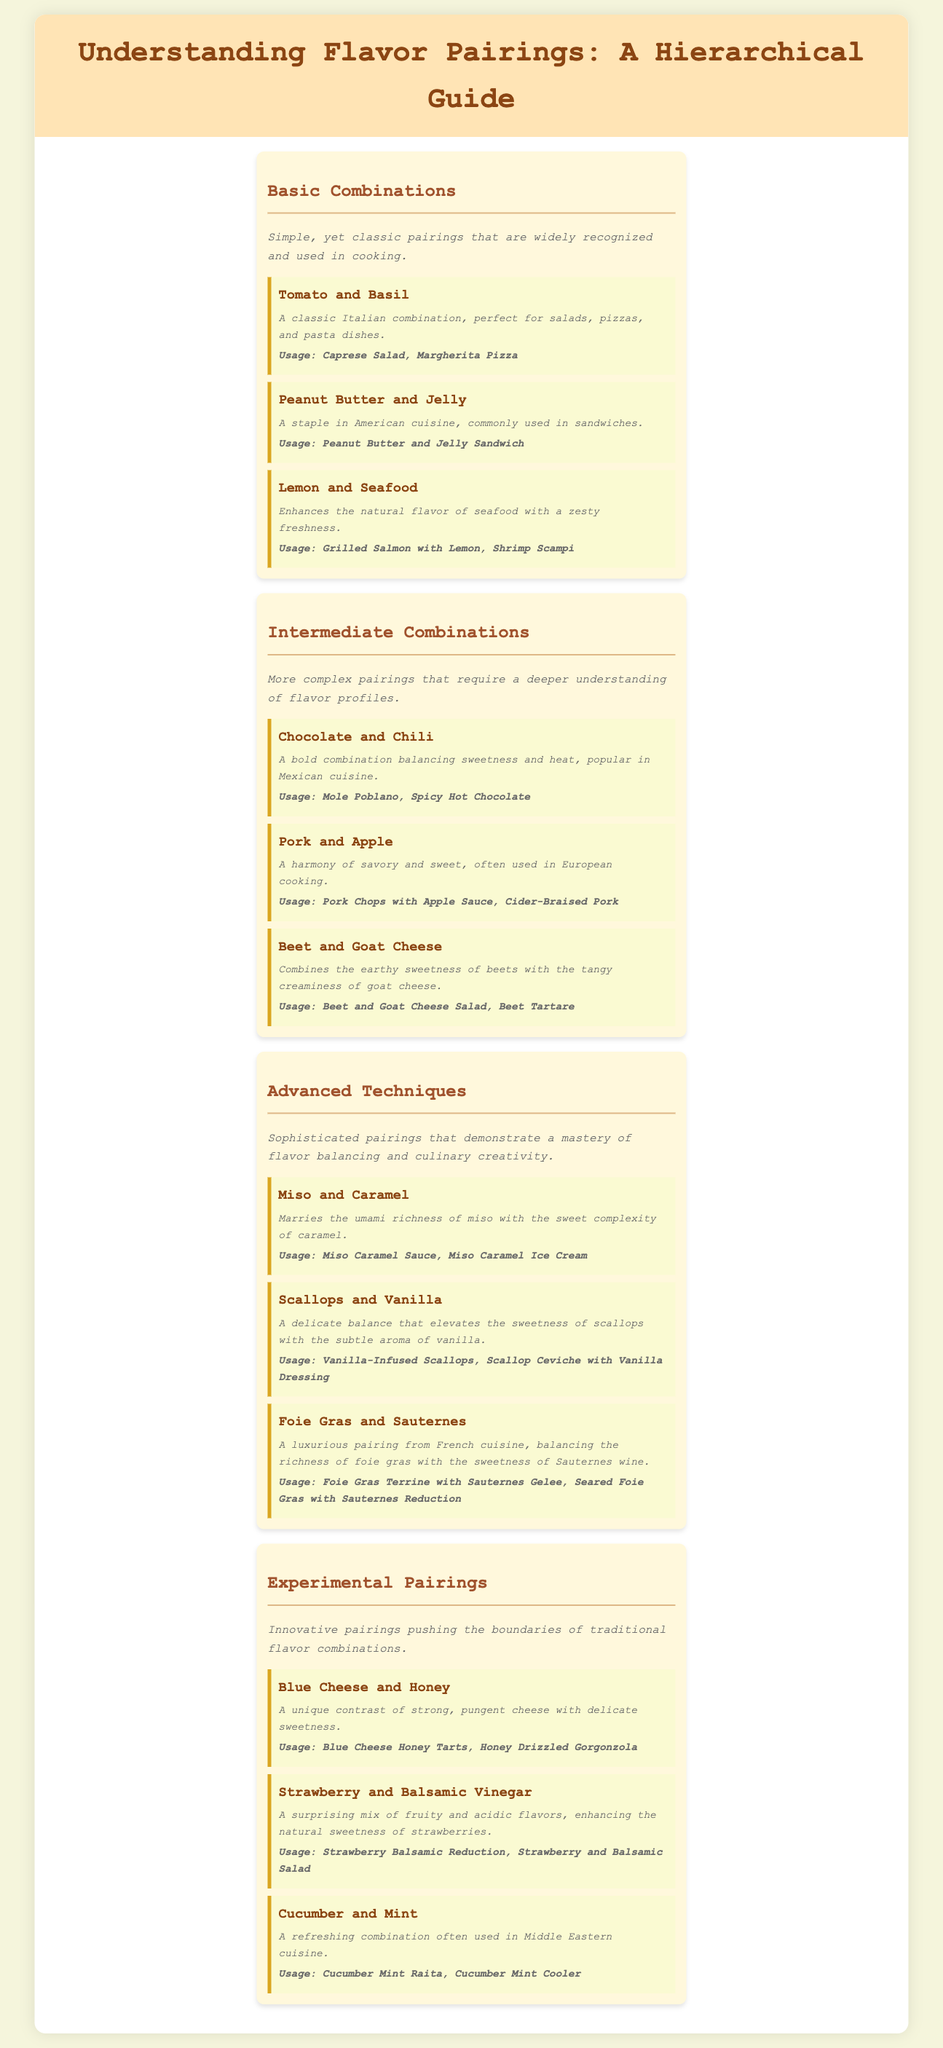What are the sections of the guide? The document contains sections that include Basic Combinations, Intermediate Combinations, Advanced Techniques, and Experimental Pairings.
Answer: Basic Combinations, Intermediate Combinations, Advanced Techniques, Experimental Pairings What is a classic pairing in Basic Combinations? The document lists Tomato and Basil as a classic pairing in Basic Combinations, which is widely recognized.
Answer: Tomato and Basil Which advanced technique combines miso with caramel? The document specifically mentions Miso and Caramel as an advanced technique pairing that showcases flavor balancing.
Answer: Miso and Caramel What ingredient is paired with chocolate in Intermediate Combinations? The document states that Chocolate is paired with Chili, creating a bold combination.
Answer: Chili What is the purpose of the Experimental Pairings section? This section highlights innovative pairings that push the boundaries of traditional flavor combinations.
Answer: Innovative pairings How is scallops paired in an advanced technique? The document describes Scallops paired with Vanilla, creating a delicate balance.
Answer: Vanilla Which combination is used in a Caprese Salad? The document lists Tomato and Basil as a classic combination, commonly used in a Caprese Salad.
Answer: Tomato and Basil What type of cuisine often uses Lemon and Seafood? The document implies that Lemon and Seafood pairings are commonly found in various cuisines, particularly Italian.
Answer: Italian What is a common usage for Pork and Apple? Pork and Apple are used in dishes like Pork Chops with Apple Sauce, according to the document.
Answer: Pork Chops with Apple Sauce 